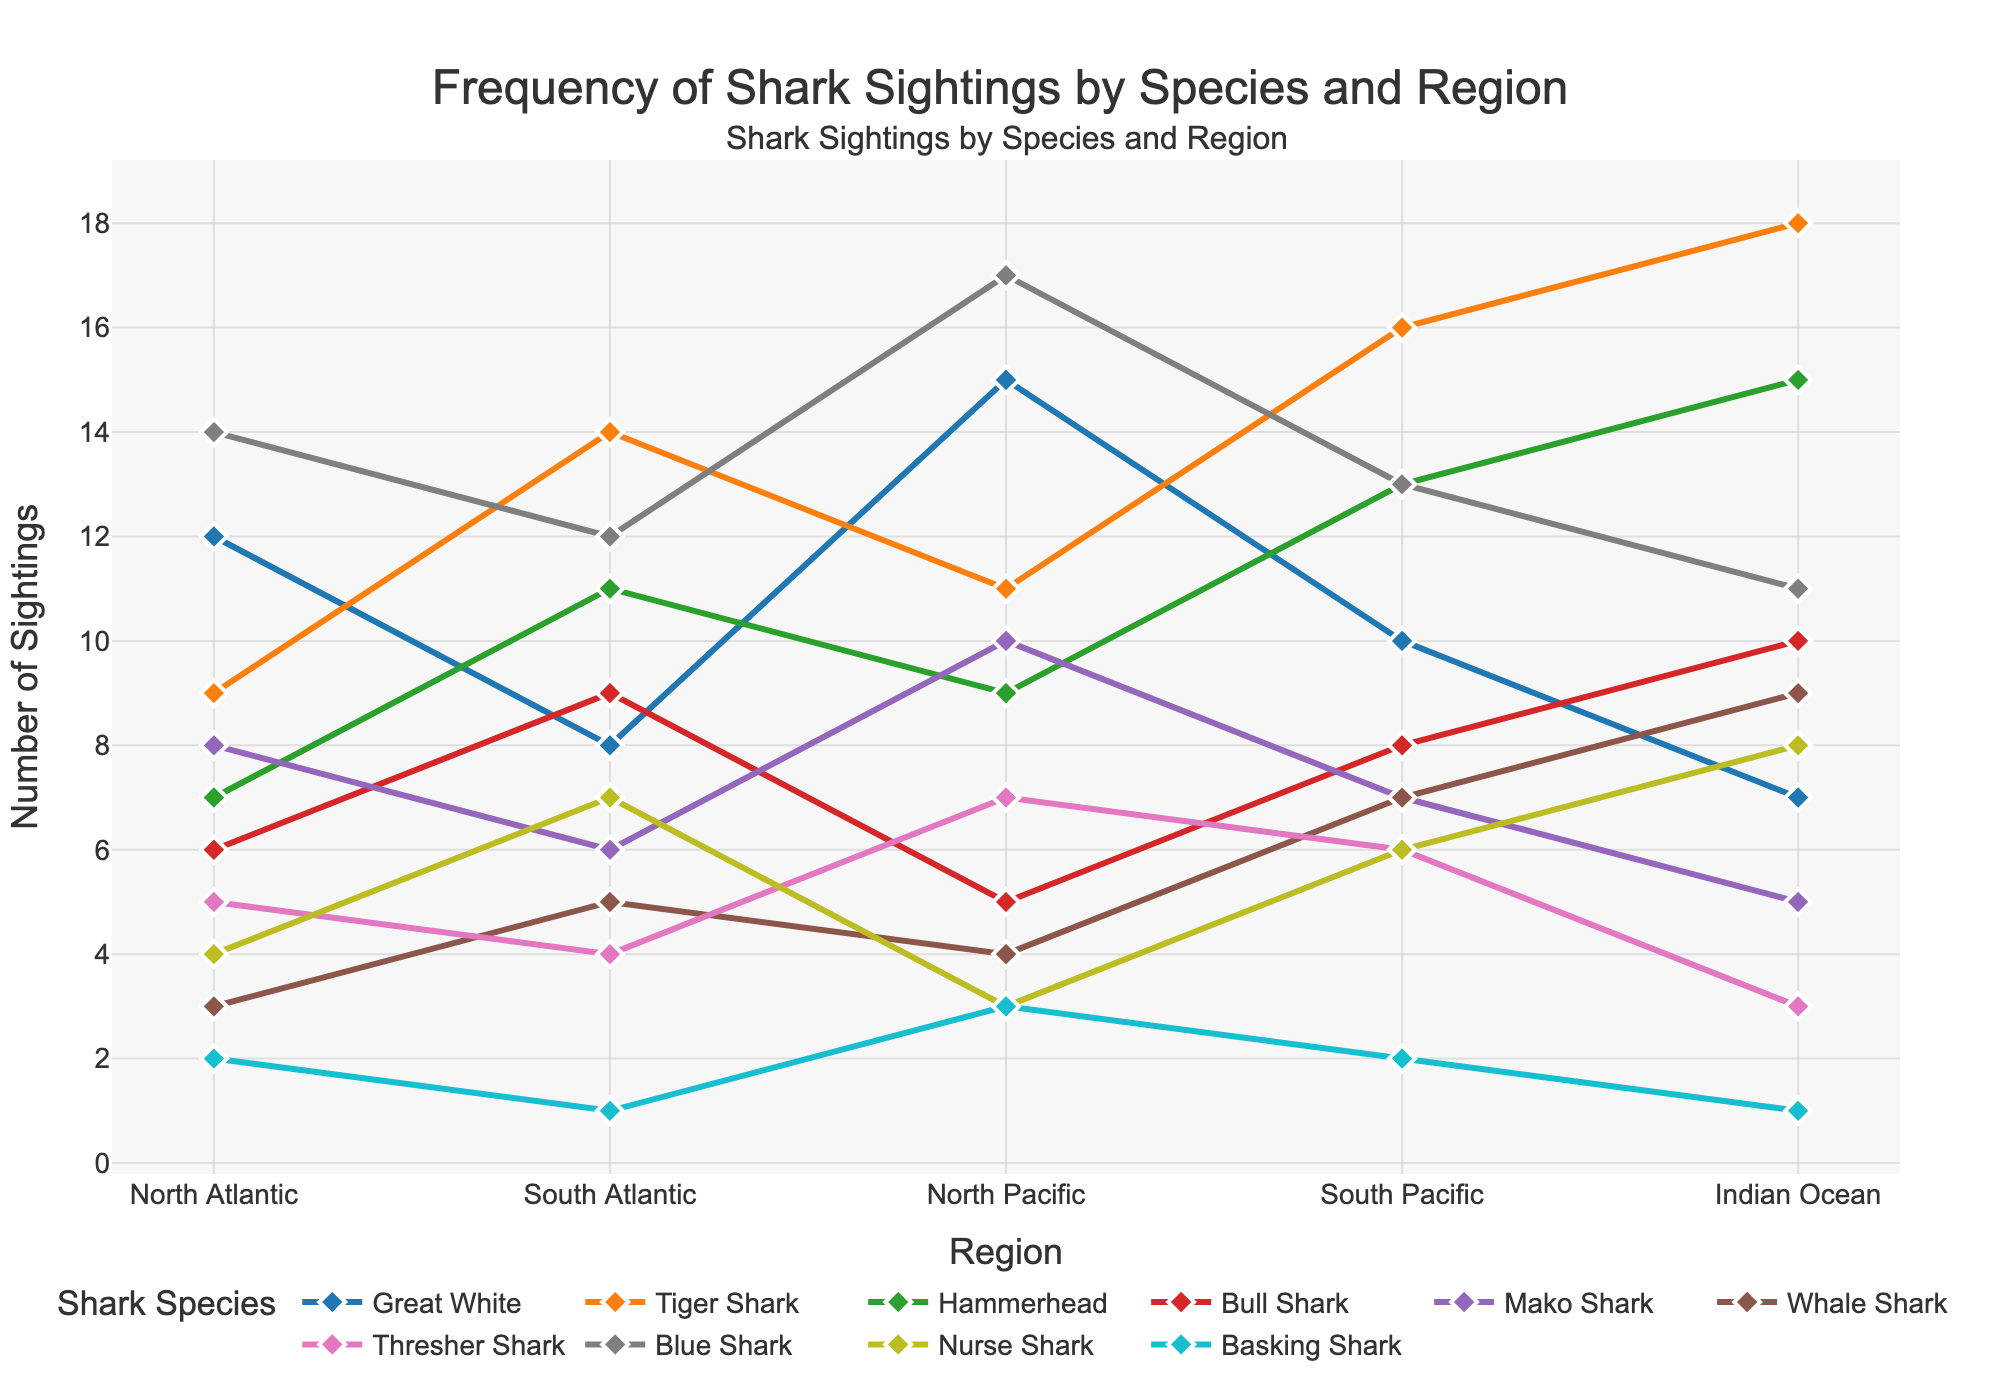What species of shark has the highest number of sightings reported in the North Pacific region? Look at the line representing the North Pacific region on the x-axis and check the highest point. The Blue Shark has the highest number of sightings at 17.
Answer: Blue Shark Which species is sighted more frequently in the Indian Ocean, Great White or Mako Shark? Identify the points corresponding to the Indian Ocean on the x-axis for both Great White and Mako Shark. Compare the values, which are 7 for Great White and 5 for Mako Shark.
Answer: Great White Are there more sightings of Hammerhead sharks in the South Atlantic or North Atlantic? Check the values of the Hammerhead shark in both regions. In the South Atlantic, the value is 11, and in the North Atlantic, it is 7.
Answer: South Atlantic How many sightings are reported for Nurse Sharks in the South Pacific compared to the North Atlantic? Identify and compare the values for Nurse Shark in both regions. In the South Pacific, there are 6 sightings, and in the North Atlantic, there are 4 sightings.
Answer: 6 vs 4 Which shark species has the least number of sightings across all regions? Review all data points in the chart and identify the species with the lowest combined number of sightings across regions. The Basking Shark has the lowest number overall.
Answer: Basking Shark What is the average number of sightings for Whale Shark across all regions? Sum the number of sightings for Whale Shark in all regions: 3+5+4+7+9 = 28. Then divide by the number of regions: 28/5 = 5.6.
Answer: 5.6 Compare the sightings of Blue Sharks in the North Pacific and South Pacific regions. Which region reports more sightings? Look at the values for Blue Sharks in both regions. The North Pacific has 17 sightings, while the South Pacific has 13.
Answer: North Pacific How do the sightings of Nurse Sharks in the Indian Ocean compare to those in the North Pacific? Check the sightings for Nurse Sharks in both regions: 8 in the Indian Ocean and 3 in the North Pacific.
Answer: More in Indian Ocean Find the species with the smallest difference in sightings between the North Atlantic and South Atlantic regions. What is the difference? Calculate the absolute difference between sightings in the North Atlantic and South Atlantic for all species. The smallest difference is for Blue Shark (difference is 14-12=2).
Answer: 2 What species of shark has the second-highest number of sightings reported in the Indian Ocean, and how many? Sort the number of sightings in the Indian Ocean and find the second highest number. Tiger Shark has 18 sightings, and Hammerhead has the second highest with 15.
Answer: Hammerhead, 15 